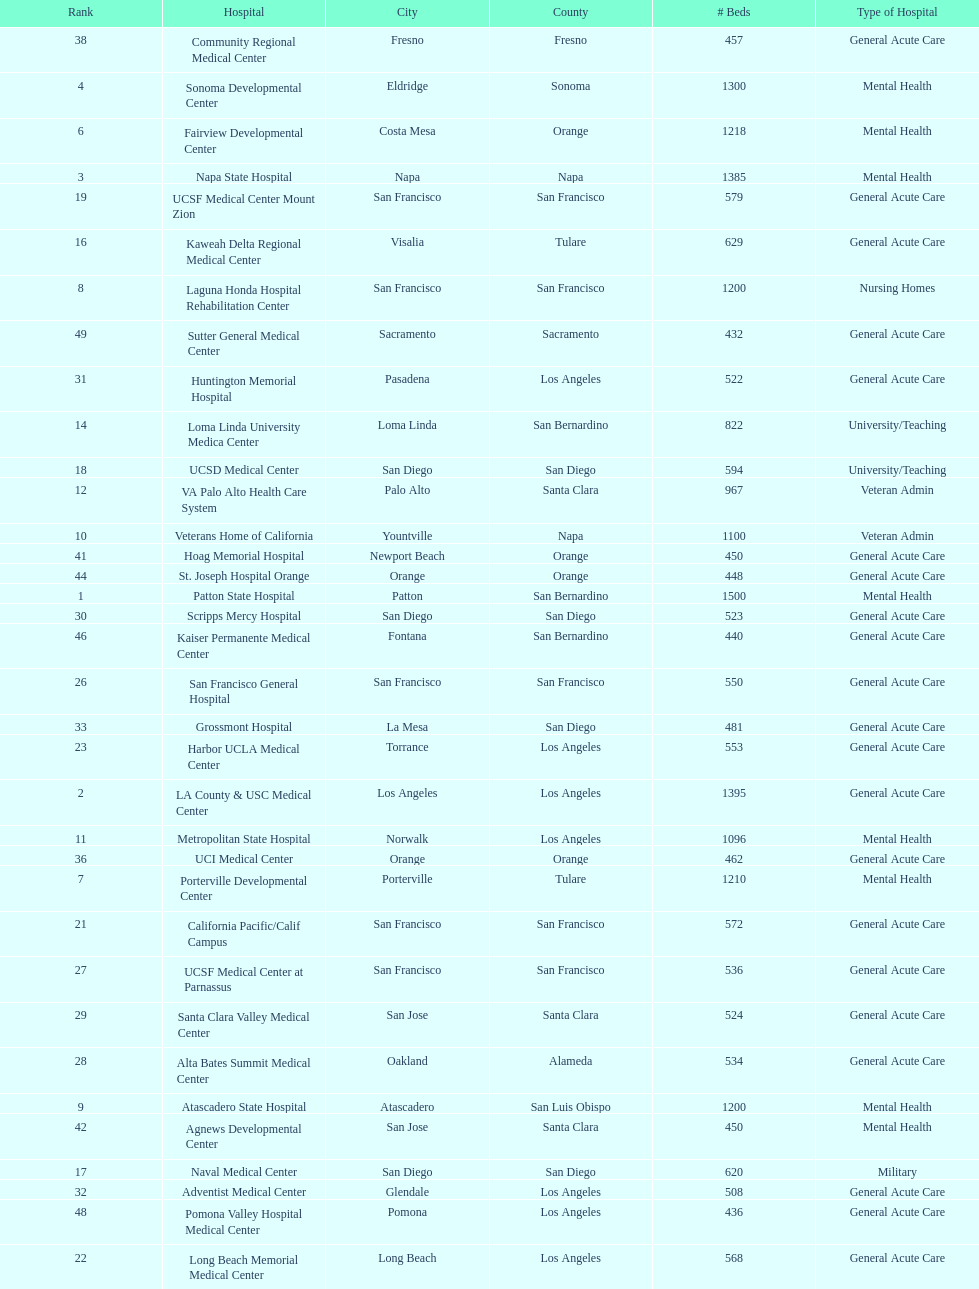What hospital in los angeles county providing hospital beds specifically for rehabilitation is ranked at least among the top 10 hospitals? Lanterman Developmental Center. 